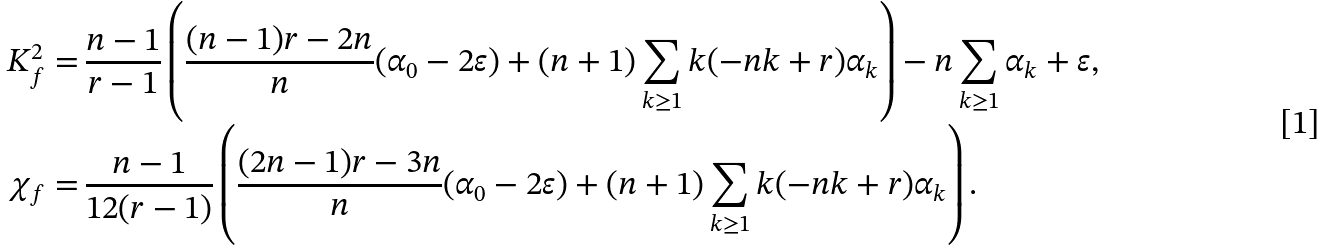<formula> <loc_0><loc_0><loc_500><loc_500>K _ { f } ^ { 2 } = & \, \frac { n - 1 } { r - 1 } \left ( \frac { ( n - 1 ) r - 2 n } { n } ( \alpha _ { 0 } - 2 \varepsilon ) + ( n + 1 ) \sum _ { k \geq 1 } k ( - n k + r ) \alpha _ { k } \right ) - n \sum _ { k \geq 1 } \alpha _ { k } + \varepsilon , \\ \chi _ { f } = & \, \frac { n - 1 } { 1 2 ( r - 1 ) } \left ( \frac { ( 2 n - 1 ) r - 3 n } { n } ( \alpha _ { 0 } - 2 \varepsilon ) + ( n + 1 ) \sum _ { k \geq 1 } k ( - n k + r ) \alpha _ { k } \right ) .</formula> 